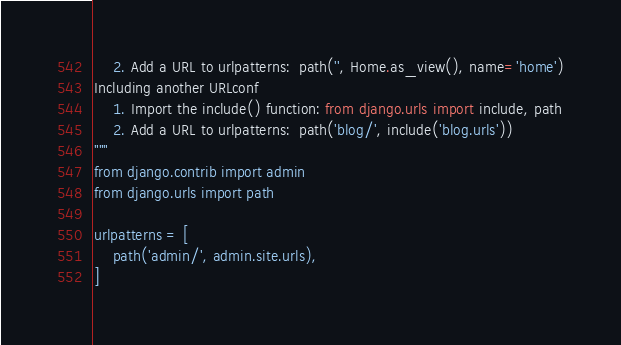<code> <loc_0><loc_0><loc_500><loc_500><_Python_>    2. Add a URL to urlpatterns:  path('', Home.as_view(), name='home')
Including another URLconf
    1. Import the include() function: from django.urls import include, path
    2. Add a URL to urlpatterns:  path('blog/', include('blog.urls'))
"""
from django.contrib import admin
from django.urls import path

urlpatterns = [
    path('admin/', admin.site.urls),
]
</code> 